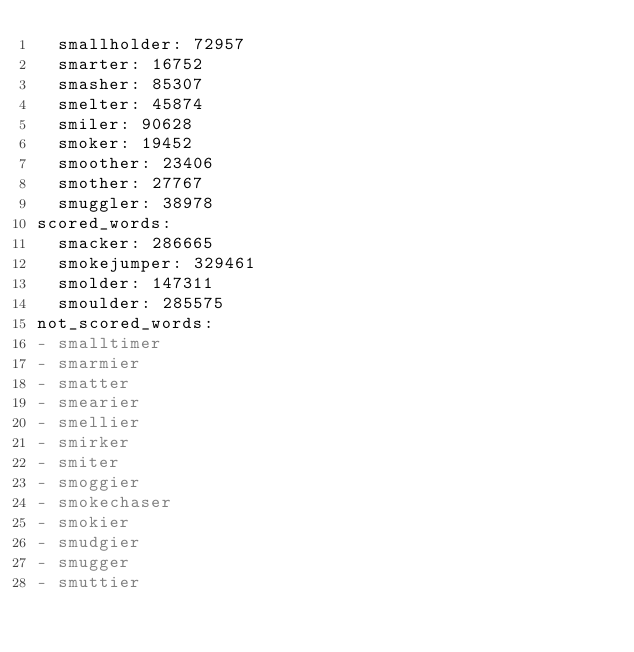Convert code to text. <code><loc_0><loc_0><loc_500><loc_500><_YAML_>  smallholder: 72957
  smarter: 16752
  smasher: 85307
  smelter: 45874
  smiler: 90628
  smoker: 19452
  smoother: 23406
  smother: 27767
  smuggler: 38978
scored_words:
  smacker: 286665
  smokejumper: 329461
  smolder: 147311
  smoulder: 285575
not_scored_words:
- smalltimer
- smarmier
- smatter
- smearier
- smellier
- smirker
- smiter
- smoggier
- smokechaser
- smokier
- smudgier
- smugger
- smuttier
</code> 